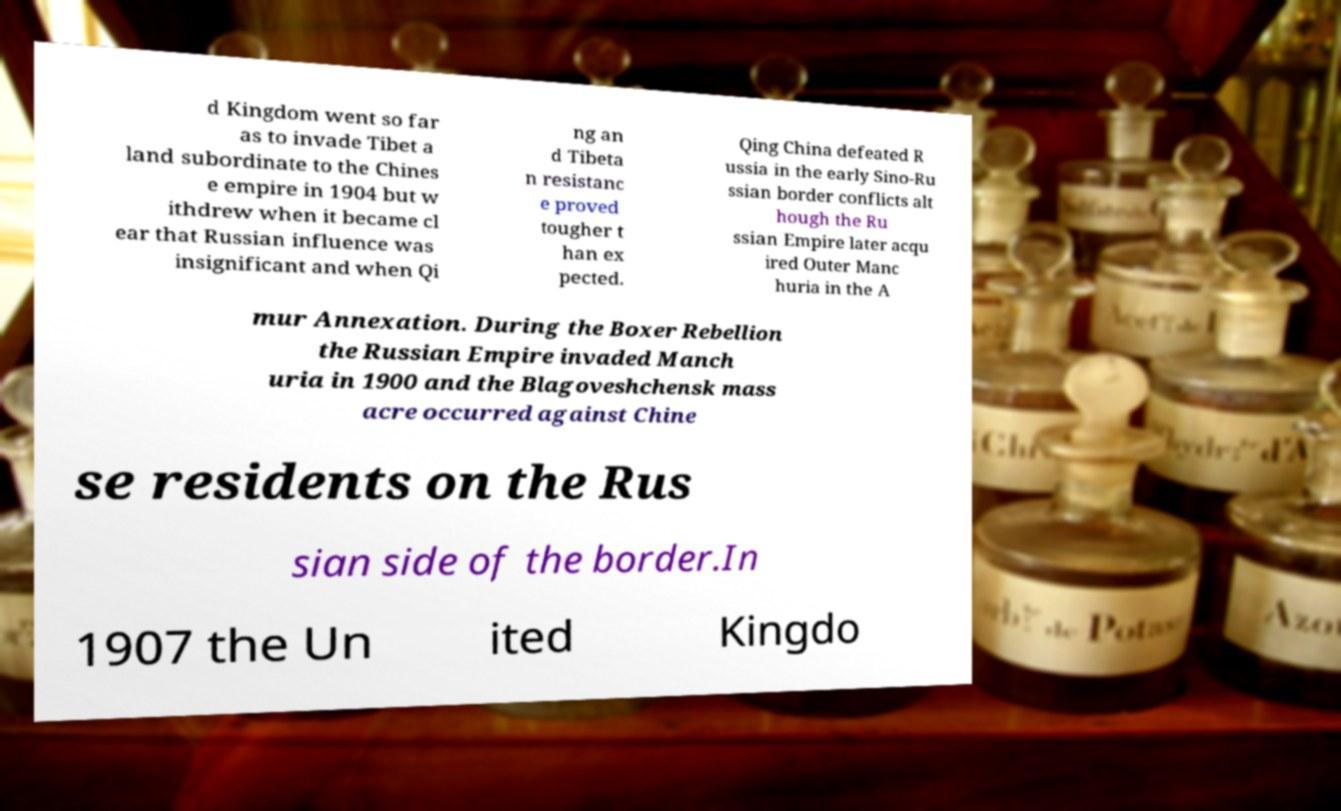Please identify and transcribe the text found in this image. d Kingdom went so far as to invade Tibet a land subordinate to the Chines e empire in 1904 but w ithdrew when it became cl ear that Russian influence was insignificant and when Qi ng an d Tibeta n resistanc e proved tougher t han ex pected. Qing China defeated R ussia in the early Sino-Ru ssian border conflicts alt hough the Ru ssian Empire later acqu ired Outer Manc huria in the A mur Annexation. During the Boxer Rebellion the Russian Empire invaded Manch uria in 1900 and the Blagoveshchensk mass acre occurred against Chine se residents on the Rus sian side of the border.In 1907 the Un ited Kingdo 